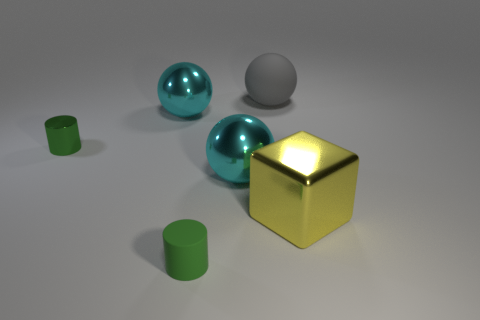How many other things are there of the same color as the small rubber thing?
Keep it short and to the point. 1. There is a object that is the same color as the tiny metal cylinder; what material is it?
Give a very brief answer. Rubber. The metal cylinder has what size?
Make the answer very short. Small. Does the shiny cylinder have the same color as the cylinder that is right of the tiny shiny thing?
Your response must be concise. Yes. What color is the small cylinder to the left of the small green cylinder in front of the large yellow shiny block?
Your answer should be compact. Green. There is a matte thing that is in front of the large rubber object; is it the same shape as the small metal object?
Your answer should be compact. Yes. How many things are in front of the large gray ball and on the right side of the tiny green shiny object?
Your response must be concise. 4. What color is the cylinder that is on the right side of the small cylinder that is behind the metallic block to the right of the tiny green metallic thing?
Offer a very short reply. Green. What number of spheres are behind the metallic thing on the right side of the gray rubber thing?
Make the answer very short. 3. What number of other things are there of the same shape as the large gray object?
Your answer should be very brief. 2. 